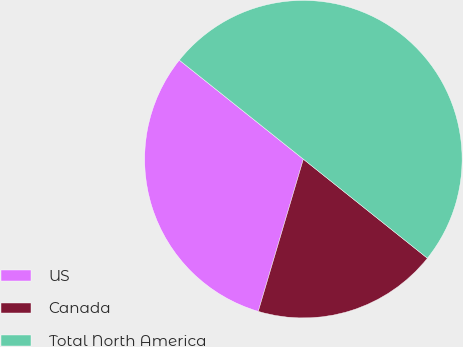Convert chart. <chart><loc_0><loc_0><loc_500><loc_500><pie_chart><fcel>US<fcel>Canada<fcel>Total North America<nl><fcel>31.14%<fcel>18.86%<fcel>50.0%<nl></chart> 